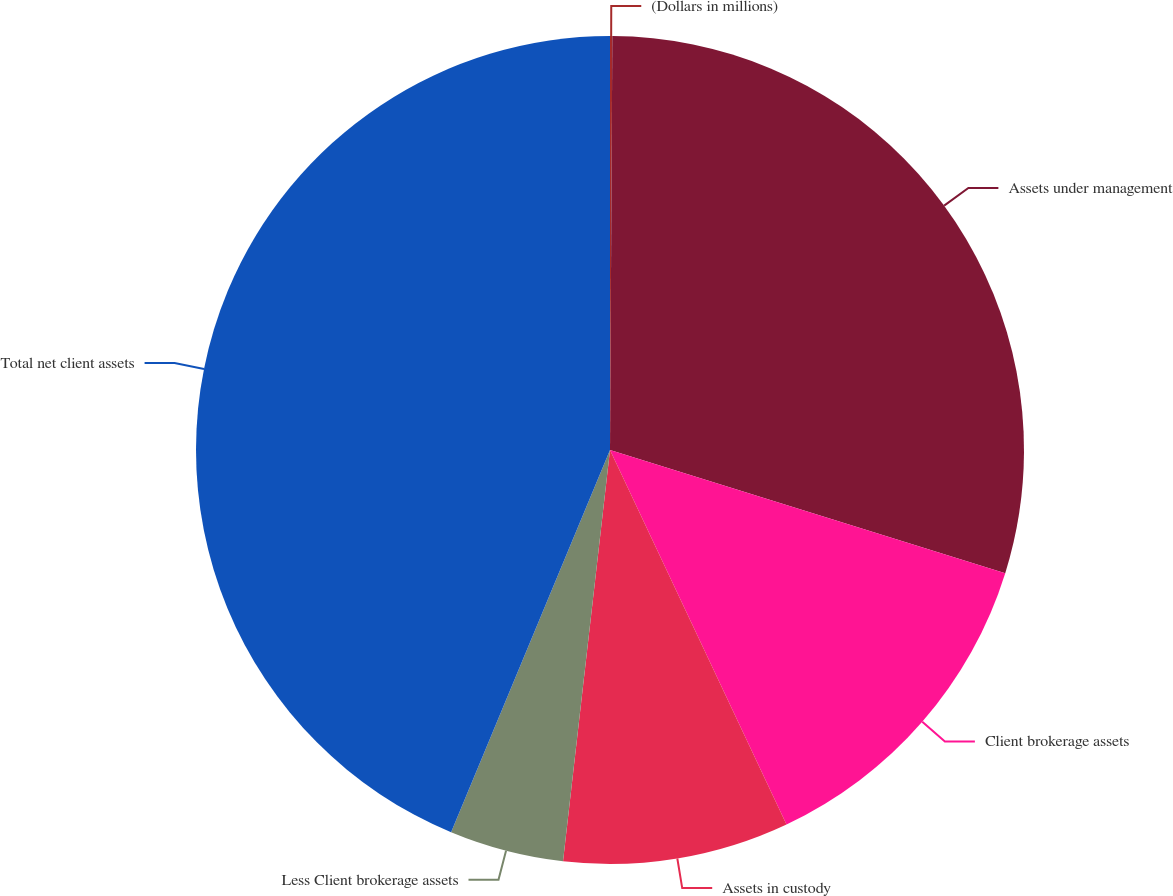<chart> <loc_0><loc_0><loc_500><loc_500><pie_chart><fcel>(Dollars in millions)<fcel>Assets under management<fcel>Client brokerage assets<fcel>Assets in custody<fcel>Less Client brokerage assets<fcel>Total net client assets<nl><fcel>0.09%<fcel>29.72%<fcel>13.18%<fcel>8.82%<fcel>4.46%<fcel>43.73%<nl></chart> 